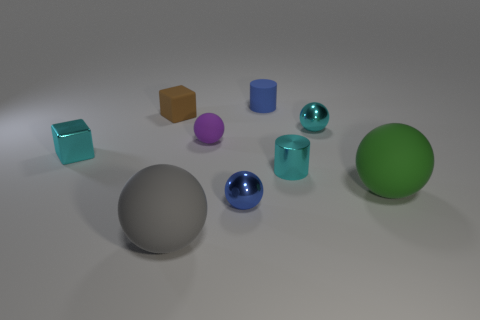There is a object that is the same color as the small rubber cylinder; what is its shape?
Offer a terse response. Sphere. What number of spheres are small brown rubber things or small rubber things?
Ensure brevity in your answer.  1. Are there the same number of brown blocks that are to the right of the tiny purple sphere and blue balls that are in front of the cyan ball?
Keep it short and to the point. No. There is a cyan object that is the same shape as the tiny brown object; what is its size?
Provide a short and direct response. Small. There is a rubber thing that is right of the tiny blue ball and in front of the small blue matte thing; what is its size?
Give a very brief answer. Large. Are there any tiny rubber balls behind the tiny blue matte thing?
Provide a succinct answer. No. What number of things are rubber balls that are to the left of the tiny cyan ball or large purple blocks?
Offer a very short reply. 2. How many metal cylinders are left of the tiny cylinder in front of the small rubber block?
Offer a very short reply. 0. Is the number of small purple matte things to the right of the blue cylinder less than the number of metal balls that are in front of the small brown rubber object?
Offer a terse response. Yes. There is a large rubber object that is on the right side of the small metal object right of the cyan metal cylinder; what is its shape?
Your answer should be very brief. Sphere. 